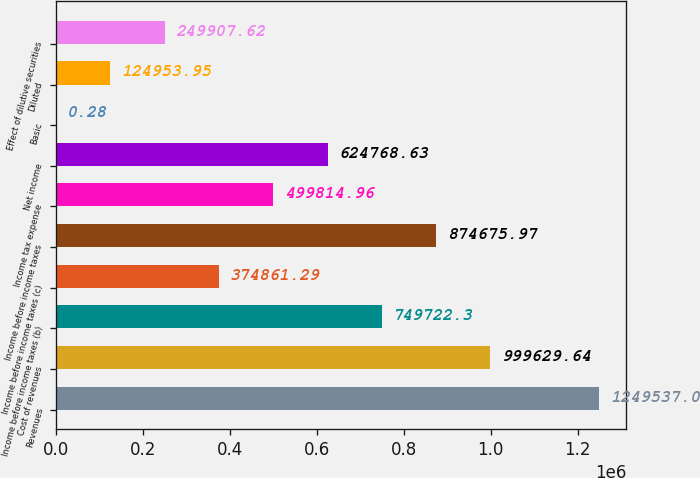Convert chart. <chart><loc_0><loc_0><loc_500><loc_500><bar_chart><fcel>Revenues<fcel>Cost of revenues<fcel>Income before income taxes (b)<fcel>Income before income taxes (c)<fcel>Income before income taxes<fcel>Income tax expense<fcel>Net income<fcel>Basic<fcel>Diluted<fcel>Effect of dilutive securities<nl><fcel>1.24954e+06<fcel>999630<fcel>749722<fcel>374861<fcel>874676<fcel>499815<fcel>624769<fcel>0.28<fcel>124954<fcel>249908<nl></chart> 